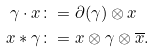<formula> <loc_0><loc_0><loc_500><loc_500>\gamma \cdot x & \colon = \partial ( \gamma ) \otimes x \\ x * \gamma & \colon = x \otimes \gamma \otimes \overline { x } .</formula> 